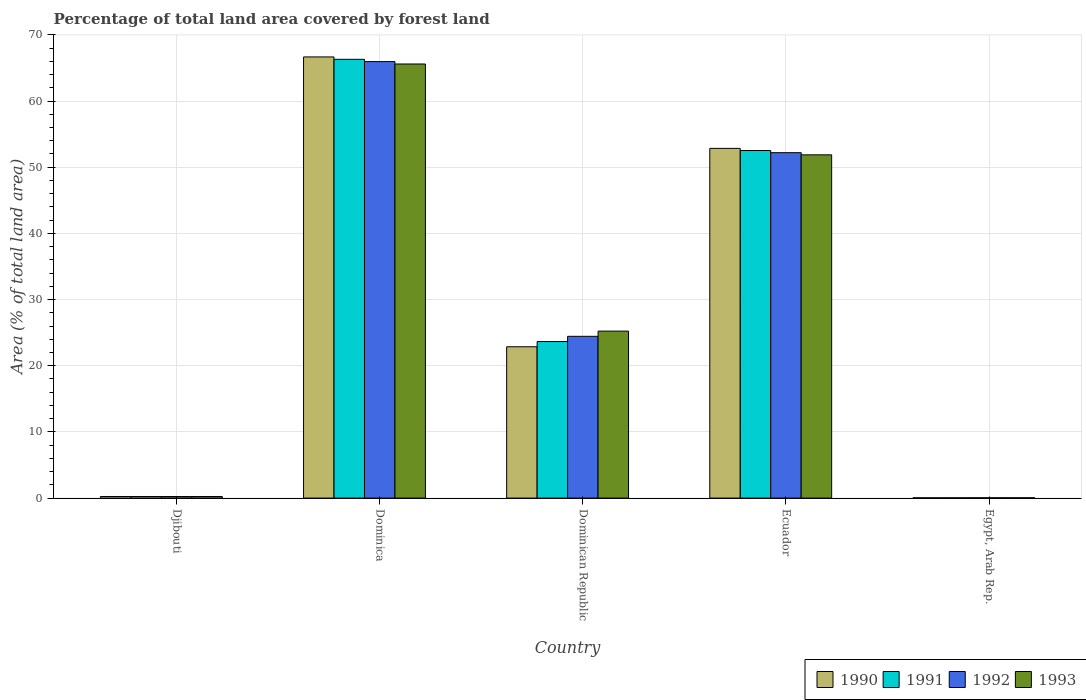How many different coloured bars are there?
Provide a succinct answer. 4. How many groups of bars are there?
Give a very brief answer. 5. Are the number of bars per tick equal to the number of legend labels?
Provide a short and direct response. Yes. What is the label of the 3rd group of bars from the left?
Make the answer very short. Dominican Republic. In how many cases, is the number of bars for a given country not equal to the number of legend labels?
Keep it short and to the point. 0. What is the percentage of forest land in 1991 in Dominican Republic?
Your answer should be very brief. 23.66. Across all countries, what is the maximum percentage of forest land in 1992?
Give a very brief answer. 65.96. Across all countries, what is the minimum percentage of forest land in 1991?
Give a very brief answer. 0.05. In which country was the percentage of forest land in 1990 maximum?
Your response must be concise. Dominica. In which country was the percentage of forest land in 1991 minimum?
Make the answer very short. Egypt, Arab Rep. What is the total percentage of forest land in 1993 in the graph?
Offer a very short reply. 143. What is the difference between the percentage of forest land in 1990 in Dominica and that in Dominican Republic?
Your answer should be very brief. 43.8. What is the difference between the percentage of forest land in 1991 in Egypt, Arab Rep. and the percentage of forest land in 1993 in Ecuador?
Ensure brevity in your answer.  -51.83. What is the average percentage of forest land in 1990 per country?
Make the answer very short. 28.53. What is the difference between the percentage of forest land of/in 1990 and percentage of forest land of/in 1993 in Dominica?
Your answer should be very brief. 1.07. What is the ratio of the percentage of forest land in 1992 in Dominica to that in Ecuador?
Your answer should be very brief. 1.26. Is the difference between the percentage of forest land in 1990 in Dominica and Dominican Republic greater than the difference between the percentage of forest land in 1993 in Dominica and Dominican Republic?
Provide a short and direct response. Yes. What is the difference between the highest and the second highest percentage of forest land in 1993?
Give a very brief answer. 13.73. What is the difference between the highest and the lowest percentage of forest land in 1990?
Ensure brevity in your answer.  66.62. In how many countries, is the percentage of forest land in 1993 greater than the average percentage of forest land in 1993 taken over all countries?
Provide a succinct answer. 2. Is the sum of the percentage of forest land in 1991 in Dominica and Ecuador greater than the maximum percentage of forest land in 1993 across all countries?
Make the answer very short. Yes. Is it the case that in every country, the sum of the percentage of forest land in 1993 and percentage of forest land in 1990 is greater than the sum of percentage of forest land in 1992 and percentage of forest land in 1991?
Provide a succinct answer. No. What does the 1st bar from the left in Ecuador represents?
Your answer should be compact. 1990. What does the 1st bar from the right in Ecuador represents?
Your answer should be compact. 1993. Is it the case that in every country, the sum of the percentage of forest land in 1991 and percentage of forest land in 1990 is greater than the percentage of forest land in 1993?
Make the answer very short. Yes. How many bars are there?
Ensure brevity in your answer.  20. How many countries are there in the graph?
Offer a very short reply. 5. Are the values on the major ticks of Y-axis written in scientific E-notation?
Your response must be concise. No. Does the graph contain any zero values?
Provide a succinct answer. No. Does the graph contain grids?
Make the answer very short. Yes. Where does the legend appear in the graph?
Provide a succinct answer. Bottom right. How many legend labels are there?
Make the answer very short. 4. How are the legend labels stacked?
Your answer should be very brief. Horizontal. What is the title of the graph?
Provide a short and direct response. Percentage of total land area covered by forest land. Does "1992" appear as one of the legend labels in the graph?
Provide a succinct answer. Yes. What is the label or title of the X-axis?
Give a very brief answer. Country. What is the label or title of the Y-axis?
Your answer should be very brief. Area (% of total land area). What is the Area (% of total land area) in 1990 in Djibouti?
Provide a succinct answer. 0.24. What is the Area (% of total land area) of 1991 in Djibouti?
Provide a succinct answer. 0.24. What is the Area (% of total land area) in 1992 in Djibouti?
Offer a very short reply. 0.24. What is the Area (% of total land area) of 1993 in Djibouti?
Keep it short and to the point. 0.24. What is the Area (% of total land area) in 1990 in Dominica?
Your answer should be very brief. 66.67. What is the Area (% of total land area) of 1991 in Dominica?
Provide a succinct answer. 66.31. What is the Area (% of total land area) in 1992 in Dominica?
Give a very brief answer. 65.96. What is the Area (% of total land area) in 1993 in Dominica?
Provide a short and direct response. 65.6. What is the Area (% of total land area) in 1990 in Dominican Republic?
Your response must be concise. 22.87. What is the Area (% of total land area) of 1991 in Dominican Republic?
Your answer should be very brief. 23.66. What is the Area (% of total land area) of 1992 in Dominican Republic?
Make the answer very short. 24.45. What is the Area (% of total land area) of 1993 in Dominican Republic?
Provide a short and direct response. 25.23. What is the Area (% of total land area) of 1990 in Ecuador?
Offer a very short reply. 52.85. What is the Area (% of total land area) of 1991 in Ecuador?
Offer a terse response. 52.52. What is the Area (% of total land area) of 1992 in Ecuador?
Make the answer very short. 52.2. What is the Area (% of total land area) in 1993 in Ecuador?
Make the answer very short. 51.87. What is the Area (% of total land area) in 1990 in Egypt, Arab Rep.?
Your response must be concise. 0.04. What is the Area (% of total land area) of 1991 in Egypt, Arab Rep.?
Keep it short and to the point. 0.05. What is the Area (% of total land area) of 1992 in Egypt, Arab Rep.?
Offer a terse response. 0.05. What is the Area (% of total land area) of 1993 in Egypt, Arab Rep.?
Your response must be concise. 0.05. Across all countries, what is the maximum Area (% of total land area) in 1990?
Give a very brief answer. 66.67. Across all countries, what is the maximum Area (% of total land area) of 1991?
Offer a very short reply. 66.31. Across all countries, what is the maximum Area (% of total land area) of 1992?
Provide a short and direct response. 65.96. Across all countries, what is the maximum Area (% of total land area) of 1993?
Provide a succinct answer. 65.6. Across all countries, what is the minimum Area (% of total land area) in 1990?
Make the answer very short. 0.04. Across all countries, what is the minimum Area (% of total land area) of 1991?
Your response must be concise. 0.05. Across all countries, what is the minimum Area (% of total land area) of 1992?
Provide a short and direct response. 0.05. Across all countries, what is the minimum Area (% of total land area) in 1993?
Provide a short and direct response. 0.05. What is the total Area (% of total land area) of 1990 in the graph?
Make the answer very short. 142.67. What is the total Area (% of total land area) of 1991 in the graph?
Offer a terse response. 142.77. What is the total Area (% of total land area) in 1992 in the graph?
Offer a very short reply. 142.89. What is the total Area (% of total land area) of 1993 in the graph?
Offer a very short reply. 143. What is the difference between the Area (% of total land area) of 1990 in Djibouti and that in Dominica?
Ensure brevity in your answer.  -66.43. What is the difference between the Area (% of total land area) of 1991 in Djibouti and that in Dominica?
Offer a very short reply. -66.07. What is the difference between the Area (% of total land area) in 1992 in Djibouti and that in Dominica?
Offer a terse response. -65.72. What is the difference between the Area (% of total land area) in 1993 in Djibouti and that in Dominica?
Your answer should be compact. -65.36. What is the difference between the Area (% of total land area) in 1990 in Djibouti and that in Dominican Republic?
Provide a succinct answer. -22.63. What is the difference between the Area (% of total land area) in 1991 in Djibouti and that in Dominican Republic?
Your answer should be compact. -23.42. What is the difference between the Area (% of total land area) in 1992 in Djibouti and that in Dominican Republic?
Keep it short and to the point. -24.2. What is the difference between the Area (% of total land area) of 1993 in Djibouti and that in Dominican Republic?
Your response must be concise. -24.99. What is the difference between the Area (% of total land area) in 1990 in Djibouti and that in Ecuador?
Keep it short and to the point. -52.61. What is the difference between the Area (% of total land area) in 1991 in Djibouti and that in Ecuador?
Make the answer very short. -52.28. What is the difference between the Area (% of total land area) of 1992 in Djibouti and that in Ecuador?
Give a very brief answer. -51.96. What is the difference between the Area (% of total land area) in 1993 in Djibouti and that in Ecuador?
Provide a succinct answer. -51.63. What is the difference between the Area (% of total land area) in 1990 in Djibouti and that in Egypt, Arab Rep.?
Make the answer very short. 0.2. What is the difference between the Area (% of total land area) of 1991 in Djibouti and that in Egypt, Arab Rep.?
Keep it short and to the point. 0.2. What is the difference between the Area (% of total land area) of 1992 in Djibouti and that in Egypt, Arab Rep.?
Your answer should be compact. 0.19. What is the difference between the Area (% of total land area) in 1993 in Djibouti and that in Egypt, Arab Rep.?
Offer a terse response. 0.19. What is the difference between the Area (% of total land area) in 1990 in Dominica and that in Dominican Republic?
Your answer should be compact. 43.8. What is the difference between the Area (% of total land area) of 1991 in Dominica and that in Dominican Republic?
Your answer should be very brief. 42.65. What is the difference between the Area (% of total land area) of 1992 in Dominica and that in Dominican Republic?
Keep it short and to the point. 41.51. What is the difference between the Area (% of total land area) in 1993 in Dominica and that in Dominican Republic?
Offer a very short reply. 40.37. What is the difference between the Area (% of total land area) of 1990 in Dominica and that in Ecuador?
Your answer should be compact. 13.82. What is the difference between the Area (% of total land area) of 1991 in Dominica and that in Ecuador?
Offer a very short reply. 13.78. What is the difference between the Area (% of total land area) in 1992 in Dominica and that in Ecuador?
Your answer should be compact. 13.76. What is the difference between the Area (% of total land area) in 1993 in Dominica and that in Ecuador?
Your response must be concise. 13.73. What is the difference between the Area (% of total land area) of 1990 in Dominica and that in Egypt, Arab Rep.?
Provide a succinct answer. 66.62. What is the difference between the Area (% of total land area) in 1991 in Dominica and that in Egypt, Arab Rep.?
Your answer should be very brief. 66.26. What is the difference between the Area (% of total land area) of 1992 in Dominica and that in Egypt, Arab Rep.?
Provide a succinct answer. 65.91. What is the difference between the Area (% of total land area) of 1993 in Dominica and that in Egypt, Arab Rep.?
Ensure brevity in your answer.  65.55. What is the difference between the Area (% of total land area) in 1990 in Dominican Republic and that in Ecuador?
Offer a terse response. -29.98. What is the difference between the Area (% of total land area) in 1991 in Dominican Republic and that in Ecuador?
Provide a short and direct response. -28.87. What is the difference between the Area (% of total land area) of 1992 in Dominican Republic and that in Ecuador?
Offer a very short reply. -27.75. What is the difference between the Area (% of total land area) of 1993 in Dominican Republic and that in Ecuador?
Keep it short and to the point. -26.64. What is the difference between the Area (% of total land area) in 1990 in Dominican Republic and that in Egypt, Arab Rep.?
Offer a very short reply. 22.82. What is the difference between the Area (% of total land area) of 1991 in Dominican Republic and that in Egypt, Arab Rep.?
Offer a terse response. 23.61. What is the difference between the Area (% of total land area) in 1992 in Dominican Republic and that in Egypt, Arab Rep.?
Keep it short and to the point. 24.4. What is the difference between the Area (% of total land area) of 1993 in Dominican Republic and that in Egypt, Arab Rep.?
Make the answer very short. 25.19. What is the difference between the Area (% of total land area) in 1990 in Ecuador and that in Egypt, Arab Rep.?
Give a very brief answer. 52.81. What is the difference between the Area (% of total land area) in 1991 in Ecuador and that in Egypt, Arab Rep.?
Make the answer very short. 52.48. What is the difference between the Area (% of total land area) of 1992 in Ecuador and that in Egypt, Arab Rep.?
Your answer should be compact. 52.15. What is the difference between the Area (% of total land area) of 1993 in Ecuador and that in Egypt, Arab Rep.?
Make the answer very short. 51.82. What is the difference between the Area (% of total land area) of 1990 in Djibouti and the Area (% of total land area) of 1991 in Dominica?
Your answer should be very brief. -66.07. What is the difference between the Area (% of total land area) in 1990 in Djibouti and the Area (% of total land area) in 1992 in Dominica?
Your response must be concise. -65.72. What is the difference between the Area (% of total land area) of 1990 in Djibouti and the Area (% of total land area) of 1993 in Dominica?
Offer a very short reply. -65.36. What is the difference between the Area (% of total land area) in 1991 in Djibouti and the Area (% of total land area) in 1992 in Dominica?
Your answer should be very brief. -65.72. What is the difference between the Area (% of total land area) of 1991 in Djibouti and the Area (% of total land area) of 1993 in Dominica?
Make the answer very short. -65.36. What is the difference between the Area (% of total land area) of 1992 in Djibouti and the Area (% of total land area) of 1993 in Dominica?
Provide a succinct answer. -65.36. What is the difference between the Area (% of total land area) of 1990 in Djibouti and the Area (% of total land area) of 1991 in Dominican Republic?
Offer a very short reply. -23.42. What is the difference between the Area (% of total land area) of 1990 in Djibouti and the Area (% of total land area) of 1992 in Dominican Republic?
Ensure brevity in your answer.  -24.2. What is the difference between the Area (% of total land area) of 1990 in Djibouti and the Area (% of total land area) of 1993 in Dominican Republic?
Give a very brief answer. -24.99. What is the difference between the Area (% of total land area) of 1991 in Djibouti and the Area (% of total land area) of 1992 in Dominican Republic?
Your response must be concise. -24.2. What is the difference between the Area (% of total land area) of 1991 in Djibouti and the Area (% of total land area) of 1993 in Dominican Republic?
Provide a succinct answer. -24.99. What is the difference between the Area (% of total land area) in 1992 in Djibouti and the Area (% of total land area) in 1993 in Dominican Republic?
Ensure brevity in your answer.  -24.99. What is the difference between the Area (% of total land area) of 1990 in Djibouti and the Area (% of total land area) of 1991 in Ecuador?
Your answer should be very brief. -52.28. What is the difference between the Area (% of total land area) in 1990 in Djibouti and the Area (% of total land area) in 1992 in Ecuador?
Offer a very short reply. -51.96. What is the difference between the Area (% of total land area) of 1990 in Djibouti and the Area (% of total land area) of 1993 in Ecuador?
Offer a terse response. -51.63. What is the difference between the Area (% of total land area) in 1991 in Djibouti and the Area (% of total land area) in 1992 in Ecuador?
Provide a short and direct response. -51.96. What is the difference between the Area (% of total land area) of 1991 in Djibouti and the Area (% of total land area) of 1993 in Ecuador?
Give a very brief answer. -51.63. What is the difference between the Area (% of total land area) of 1992 in Djibouti and the Area (% of total land area) of 1993 in Ecuador?
Give a very brief answer. -51.63. What is the difference between the Area (% of total land area) of 1990 in Djibouti and the Area (% of total land area) of 1991 in Egypt, Arab Rep.?
Ensure brevity in your answer.  0.2. What is the difference between the Area (% of total land area) in 1990 in Djibouti and the Area (% of total land area) in 1992 in Egypt, Arab Rep.?
Provide a short and direct response. 0.19. What is the difference between the Area (% of total land area) of 1990 in Djibouti and the Area (% of total land area) of 1993 in Egypt, Arab Rep.?
Give a very brief answer. 0.19. What is the difference between the Area (% of total land area) of 1991 in Djibouti and the Area (% of total land area) of 1992 in Egypt, Arab Rep.?
Make the answer very short. 0.19. What is the difference between the Area (% of total land area) of 1991 in Djibouti and the Area (% of total land area) of 1993 in Egypt, Arab Rep.?
Offer a very short reply. 0.19. What is the difference between the Area (% of total land area) in 1992 in Djibouti and the Area (% of total land area) in 1993 in Egypt, Arab Rep.?
Your answer should be very brief. 0.19. What is the difference between the Area (% of total land area) of 1990 in Dominica and the Area (% of total land area) of 1991 in Dominican Republic?
Keep it short and to the point. 43.01. What is the difference between the Area (% of total land area) of 1990 in Dominica and the Area (% of total land area) of 1992 in Dominican Republic?
Offer a terse response. 42.22. What is the difference between the Area (% of total land area) of 1990 in Dominica and the Area (% of total land area) of 1993 in Dominican Republic?
Make the answer very short. 41.43. What is the difference between the Area (% of total land area) in 1991 in Dominica and the Area (% of total land area) in 1992 in Dominican Republic?
Keep it short and to the point. 41.86. What is the difference between the Area (% of total land area) in 1991 in Dominica and the Area (% of total land area) in 1993 in Dominican Republic?
Offer a very short reply. 41.07. What is the difference between the Area (% of total land area) in 1992 in Dominica and the Area (% of total land area) in 1993 in Dominican Republic?
Provide a succinct answer. 40.73. What is the difference between the Area (% of total land area) in 1990 in Dominica and the Area (% of total land area) in 1991 in Ecuador?
Offer a very short reply. 14.14. What is the difference between the Area (% of total land area) of 1990 in Dominica and the Area (% of total land area) of 1992 in Ecuador?
Make the answer very short. 14.47. What is the difference between the Area (% of total land area) of 1990 in Dominica and the Area (% of total land area) of 1993 in Ecuador?
Make the answer very short. 14.79. What is the difference between the Area (% of total land area) of 1991 in Dominica and the Area (% of total land area) of 1992 in Ecuador?
Provide a short and direct response. 14.11. What is the difference between the Area (% of total land area) of 1991 in Dominica and the Area (% of total land area) of 1993 in Ecuador?
Offer a very short reply. 14.43. What is the difference between the Area (% of total land area) in 1992 in Dominica and the Area (% of total land area) in 1993 in Ecuador?
Your answer should be very brief. 14.09. What is the difference between the Area (% of total land area) of 1990 in Dominica and the Area (% of total land area) of 1991 in Egypt, Arab Rep.?
Keep it short and to the point. 66.62. What is the difference between the Area (% of total land area) in 1990 in Dominica and the Area (% of total land area) in 1992 in Egypt, Arab Rep.?
Your response must be concise. 66.62. What is the difference between the Area (% of total land area) in 1990 in Dominica and the Area (% of total land area) in 1993 in Egypt, Arab Rep.?
Offer a very short reply. 66.62. What is the difference between the Area (% of total land area) in 1991 in Dominica and the Area (% of total land area) in 1992 in Egypt, Arab Rep.?
Provide a succinct answer. 66.26. What is the difference between the Area (% of total land area) in 1991 in Dominica and the Area (% of total land area) in 1993 in Egypt, Arab Rep.?
Give a very brief answer. 66.26. What is the difference between the Area (% of total land area) of 1992 in Dominica and the Area (% of total land area) of 1993 in Egypt, Arab Rep.?
Offer a very short reply. 65.91. What is the difference between the Area (% of total land area) of 1990 in Dominican Republic and the Area (% of total land area) of 1991 in Ecuador?
Give a very brief answer. -29.66. What is the difference between the Area (% of total land area) in 1990 in Dominican Republic and the Area (% of total land area) in 1992 in Ecuador?
Make the answer very short. -29.33. What is the difference between the Area (% of total land area) of 1990 in Dominican Republic and the Area (% of total land area) of 1993 in Ecuador?
Your response must be concise. -29. What is the difference between the Area (% of total land area) in 1991 in Dominican Republic and the Area (% of total land area) in 1992 in Ecuador?
Your answer should be very brief. -28.54. What is the difference between the Area (% of total land area) in 1991 in Dominican Republic and the Area (% of total land area) in 1993 in Ecuador?
Your answer should be very brief. -28.22. What is the difference between the Area (% of total land area) in 1992 in Dominican Republic and the Area (% of total land area) in 1993 in Ecuador?
Your response must be concise. -27.43. What is the difference between the Area (% of total land area) in 1990 in Dominican Republic and the Area (% of total land area) in 1991 in Egypt, Arab Rep.?
Provide a short and direct response. 22.82. What is the difference between the Area (% of total land area) in 1990 in Dominican Republic and the Area (% of total land area) in 1992 in Egypt, Arab Rep.?
Give a very brief answer. 22.82. What is the difference between the Area (% of total land area) in 1990 in Dominican Republic and the Area (% of total land area) in 1993 in Egypt, Arab Rep.?
Your answer should be compact. 22.82. What is the difference between the Area (% of total land area) of 1991 in Dominican Republic and the Area (% of total land area) of 1992 in Egypt, Arab Rep.?
Your response must be concise. 23.61. What is the difference between the Area (% of total land area) of 1991 in Dominican Republic and the Area (% of total land area) of 1993 in Egypt, Arab Rep.?
Offer a terse response. 23.61. What is the difference between the Area (% of total land area) in 1992 in Dominican Republic and the Area (% of total land area) in 1993 in Egypt, Arab Rep.?
Make the answer very short. 24.4. What is the difference between the Area (% of total land area) of 1990 in Ecuador and the Area (% of total land area) of 1991 in Egypt, Arab Rep.?
Provide a succinct answer. 52.8. What is the difference between the Area (% of total land area) in 1990 in Ecuador and the Area (% of total land area) in 1992 in Egypt, Arab Rep.?
Provide a short and direct response. 52.8. What is the difference between the Area (% of total land area) in 1990 in Ecuador and the Area (% of total land area) in 1993 in Egypt, Arab Rep.?
Your answer should be compact. 52.8. What is the difference between the Area (% of total land area) of 1991 in Ecuador and the Area (% of total land area) of 1992 in Egypt, Arab Rep.?
Make the answer very short. 52.48. What is the difference between the Area (% of total land area) of 1991 in Ecuador and the Area (% of total land area) of 1993 in Egypt, Arab Rep.?
Give a very brief answer. 52.47. What is the difference between the Area (% of total land area) in 1992 in Ecuador and the Area (% of total land area) in 1993 in Egypt, Arab Rep.?
Ensure brevity in your answer.  52.15. What is the average Area (% of total land area) of 1990 per country?
Ensure brevity in your answer.  28.53. What is the average Area (% of total land area) of 1991 per country?
Provide a short and direct response. 28.55. What is the average Area (% of total land area) of 1992 per country?
Your answer should be very brief. 28.58. What is the average Area (% of total land area) of 1993 per country?
Your answer should be very brief. 28.6. What is the difference between the Area (% of total land area) in 1990 and Area (% of total land area) in 1991 in Djibouti?
Ensure brevity in your answer.  0. What is the difference between the Area (% of total land area) in 1990 and Area (% of total land area) in 1992 in Djibouti?
Your answer should be very brief. 0. What is the difference between the Area (% of total land area) of 1990 and Area (% of total land area) of 1993 in Djibouti?
Your answer should be compact. 0. What is the difference between the Area (% of total land area) of 1991 and Area (% of total land area) of 1992 in Djibouti?
Your answer should be very brief. 0. What is the difference between the Area (% of total land area) of 1990 and Area (% of total land area) of 1991 in Dominica?
Make the answer very short. 0.36. What is the difference between the Area (% of total land area) of 1990 and Area (% of total land area) of 1992 in Dominica?
Provide a succinct answer. 0.71. What is the difference between the Area (% of total land area) in 1990 and Area (% of total land area) in 1993 in Dominica?
Provide a succinct answer. 1.07. What is the difference between the Area (% of total land area) of 1991 and Area (% of total land area) of 1992 in Dominica?
Make the answer very short. 0.35. What is the difference between the Area (% of total land area) in 1991 and Area (% of total land area) in 1993 in Dominica?
Your answer should be compact. 0.71. What is the difference between the Area (% of total land area) in 1992 and Area (% of total land area) in 1993 in Dominica?
Give a very brief answer. 0.36. What is the difference between the Area (% of total land area) of 1990 and Area (% of total land area) of 1991 in Dominican Republic?
Give a very brief answer. -0.79. What is the difference between the Area (% of total land area) of 1990 and Area (% of total land area) of 1992 in Dominican Republic?
Offer a terse response. -1.58. What is the difference between the Area (% of total land area) of 1990 and Area (% of total land area) of 1993 in Dominican Republic?
Your answer should be very brief. -2.37. What is the difference between the Area (% of total land area) in 1991 and Area (% of total land area) in 1992 in Dominican Republic?
Your answer should be compact. -0.79. What is the difference between the Area (% of total land area) of 1991 and Area (% of total land area) of 1993 in Dominican Republic?
Offer a very short reply. -1.58. What is the difference between the Area (% of total land area) of 1992 and Area (% of total land area) of 1993 in Dominican Republic?
Offer a very short reply. -0.79. What is the difference between the Area (% of total land area) of 1990 and Area (% of total land area) of 1991 in Ecuador?
Ensure brevity in your answer.  0.33. What is the difference between the Area (% of total land area) in 1990 and Area (% of total land area) in 1992 in Ecuador?
Ensure brevity in your answer.  0.65. What is the difference between the Area (% of total land area) of 1990 and Area (% of total land area) of 1993 in Ecuador?
Offer a terse response. 0.98. What is the difference between the Area (% of total land area) of 1991 and Area (% of total land area) of 1992 in Ecuador?
Give a very brief answer. 0.33. What is the difference between the Area (% of total land area) in 1991 and Area (% of total land area) in 1993 in Ecuador?
Your answer should be very brief. 0.65. What is the difference between the Area (% of total land area) in 1992 and Area (% of total land area) in 1993 in Ecuador?
Offer a very short reply. 0.33. What is the difference between the Area (% of total land area) in 1990 and Area (% of total land area) in 1991 in Egypt, Arab Rep.?
Keep it short and to the point. -0. What is the difference between the Area (% of total land area) of 1990 and Area (% of total land area) of 1992 in Egypt, Arab Rep.?
Your answer should be compact. -0. What is the difference between the Area (% of total land area) in 1990 and Area (% of total land area) in 1993 in Egypt, Arab Rep.?
Give a very brief answer. -0. What is the difference between the Area (% of total land area) of 1991 and Area (% of total land area) of 1992 in Egypt, Arab Rep.?
Your response must be concise. -0. What is the difference between the Area (% of total land area) of 1991 and Area (% of total land area) of 1993 in Egypt, Arab Rep.?
Provide a succinct answer. -0. What is the difference between the Area (% of total land area) in 1992 and Area (% of total land area) in 1993 in Egypt, Arab Rep.?
Provide a short and direct response. -0. What is the ratio of the Area (% of total land area) in 1990 in Djibouti to that in Dominica?
Give a very brief answer. 0. What is the ratio of the Area (% of total land area) of 1991 in Djibouti to that in Dominica?
Give a very brief answer. 0. What is the ratio of the Area (% of total land area) in 1992 in Djibouti to that in Dominica?
Your response must be concise. 0. What is the ratio of the Area (% of total land area) in 1993 in Djibouti to that in Dominica?
Your answer should be very brief. 0. What is the ratio of the Area (% of total land area) in 1990 in Djibouti to that in Dominican Republic?
Give a very brief answer. 0.01. What is the ratio of the Area (% of total land area) of 1991 in Djibouti to that in Dominican Republic?
Provide a short and direct response. 0.01. What is the ratio of the Area (% of total land area) of 1992 in Djibouti to that in Dominican Republic?
Provide a short and direct response. 0.01. What is the ratio of the Area (% of total land area) in 1993 in Djibouti to that in Dominican Republic?
Your answer should be very brief. 0.01. What is the ratio of the Area (% of total land area) of 1990 in Djibouti to that in Ecuador?
Provide a short and direct response. 0. What is the ratio of the Area (% of total land area) of 1991 in Djibouti to that in Ecuador?
Your response must be concise. 0. What is the ratio of the Area (% of total land area) in 1992 in Djibouti to that in Ecuador?
Your answer should be compact. 0. What is the ratio of the Area (% of total land area) in 1993 in Djibouti to that in Ecuador?
Give a very brief answer. 0. What is the ratio of the Area (% of total land area) in 1990 in Djibouti to that in Egypt, Arab Rep.?
Your answer should be very brief. 5.47. What is the ratio of the Area (% of total land area) in 1991 in Djibouti to that in Egypt, Arab Rep.?
Your answer should be very brief. 5.29. What is the ratio of the Area (% of total land area) of 1992 in Djibouti to that in Egypt, Arab Rep.?
Offer a terse response. 5.12. What is the ratio of the Area (% of total land area) in 1993 in Djibouti to that in Egypt, Arab Rep.?
Provide a succinct answer. 4.96. What is the ratio of the Area (% of total land area) of 1990 in Dominica to that in Dominican Republic?
Offer a very short reply. 2.92. What is the ratio of the Area (% of total land area) of 1991 in Dominica to that in Dominican Republic?
Give a very brief answer. 2.8. What is the ratio of the Area (% of total land area) in 1992 in Dominica to that in Dominican Republic?
Provide a short and direct response. 2.7. What is the ratio of the Area (% of total land area) in 1993 in Dominica to that in Dominican Republic?
Your answer should be very brief. 2.6. What is the ratio of the Area (% of total land area) of 1990 in Dominica to that in Ecuador?
Provide a short and direct response. 1.26. What is the ratio of the Area (% of total land area) in 1991 in Dominica to that in Ecuador?
Provide a succinct answer. 1.26. What is the ratio of the Area (% of total land area) of 1992 in Dominica to that in Ecuador?
Offer a very short reply. 1.26. What is the ratio of the Area (% of total land area) in 1993 in Dominica to that in Ecuador?
Offer a terse response. 1.26. What is the ratio of the Area (% of total land area) of 1990 in Dominica to that in Egypt, Arab Rep.?
Provide a short and direct response. 1508.26. What is the ratio of the Area (% of total land area) in 1991 in Dominica to that in Egypt, Arab Rep.?
Make the answer very short. 1450.66. What is the ratio of the Area (% of total land area) of 1992 in Dominica to that in Egypt, Arab Rep.?
Provide a succinct answer. 1397.02. What is the ratio of the Area (% of total land area) of 1993 in Dominica to that in Egypt, Arab Rep.?
Your answer should be very brief. 1346.42. What is the ratio of the Area (% of total land area) of 1990 in Dominican Republic to that in Ecuador?
Provide a short and direct response. 0.43. What is the ratio of the Area (% of total land area) in 1991 in Dominican Republic to that in Ecuador?
Provide a short and direct response. 0.45. What is the ratio of the Area (% of total land area) of 1992 in Dominican Republic to that in Ecuador?
Keep it short and to the point. 0.47. What is the ratio of the Area (% of total land area) of 1993 in Dominican Republic to that in Ecuador?
Provide a short and direct response. 0.49. What is the ratio of the Area (% of total land area) in 1990 in Dominican Republic to that in Egypt, Arab Rep.?
Keep it short and to the point. 517.37. What is the ratio of the Area (% of total land area) in 1991 in Dominican Republic to that in Egypt, Arab Rep.?
Offer a very short reply. 517.57. What is the ratio of the Area (% of total land area) of 1992 in Dominican Republic to that in Egypt, Arab Rep.?
Offer a terse response. 517.75. What is the ratio of the Area (% of total land area) of 1993 in Dominican Republic to that in Egypt, Arab Rep.?
Your response must be concise. 517.92. What is the ratio of the Area (% of total land area) of 1990 in Ecuador to that in Egypt, Arab Rep.?
Offer a terse response. 1195.66. What is the ratio of the Area (% of total land area) in 1991 in Ecuador to that in Egypt, Arab Rep.?
Your response must be concise. 1149.11. What is the ratio of the Area (% of total land area) of 1992 in Ecuador to that in Egypt, Arab Rep.?
Your answer should be compact. 1105.54. What is the ratio of the Area (% of total land area) of 1993 in Ecuador to that in Egypt, Arab Rep.?
Give a very brief answer. 1064.66. What is the difference between the highest and the second highest Area (% of total land area) of 1990?
Offer a terse response. 13.82. What is the difference between the highest and the second highest Area (% of total land area) of 1991?
Make the answer very short. 13.78. What is the difference between the highest and the second highest Area (% of total land area) in 1992?
Your answer should be compact. 13.76. What is the difference between the highest and the second highest Area (% of total land area) of 1993?
Your answer should be compact. 13.73. What is the difference between the highest and the lowest Area (% of total land area) in 1990?
Your answer should be compact. 66.62. What is the difference between the highest and the lowest Area (% of total land area) in 1991?
Provide a succinct answer. 66.26. What is the difference between the highest and the lowest Area (% of total land area) of 1992?
Make the answer very short. 65.91. What is the difference between the highest and the lowest Area (% of total land area) of 1993?
Make the answer very short. 65.55. 